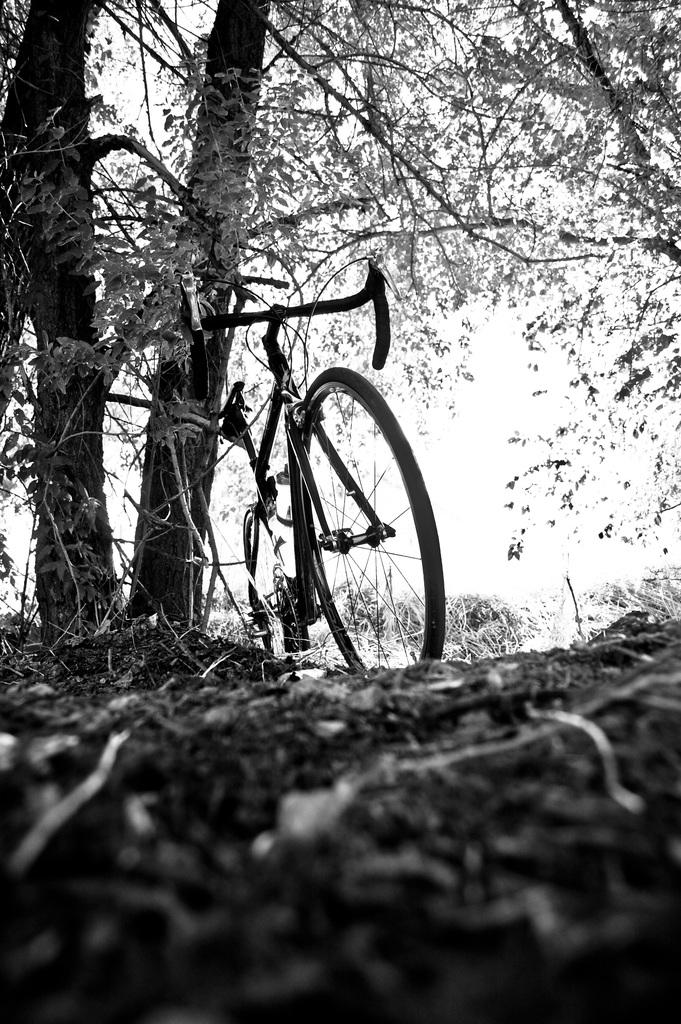What is the color scheme of the image? The image is black and white. What mode of transportation can be seen in the image? There is a cycle in the image. What type of vegetation is present in the image? There are trees in the image. What can be seen in the background of the image? The sky is visible in the background of the image. What team made the discovery depicted in the image? There is no discovery or team mentioned in the image; it features a cycle and trees in a black and white setting. 